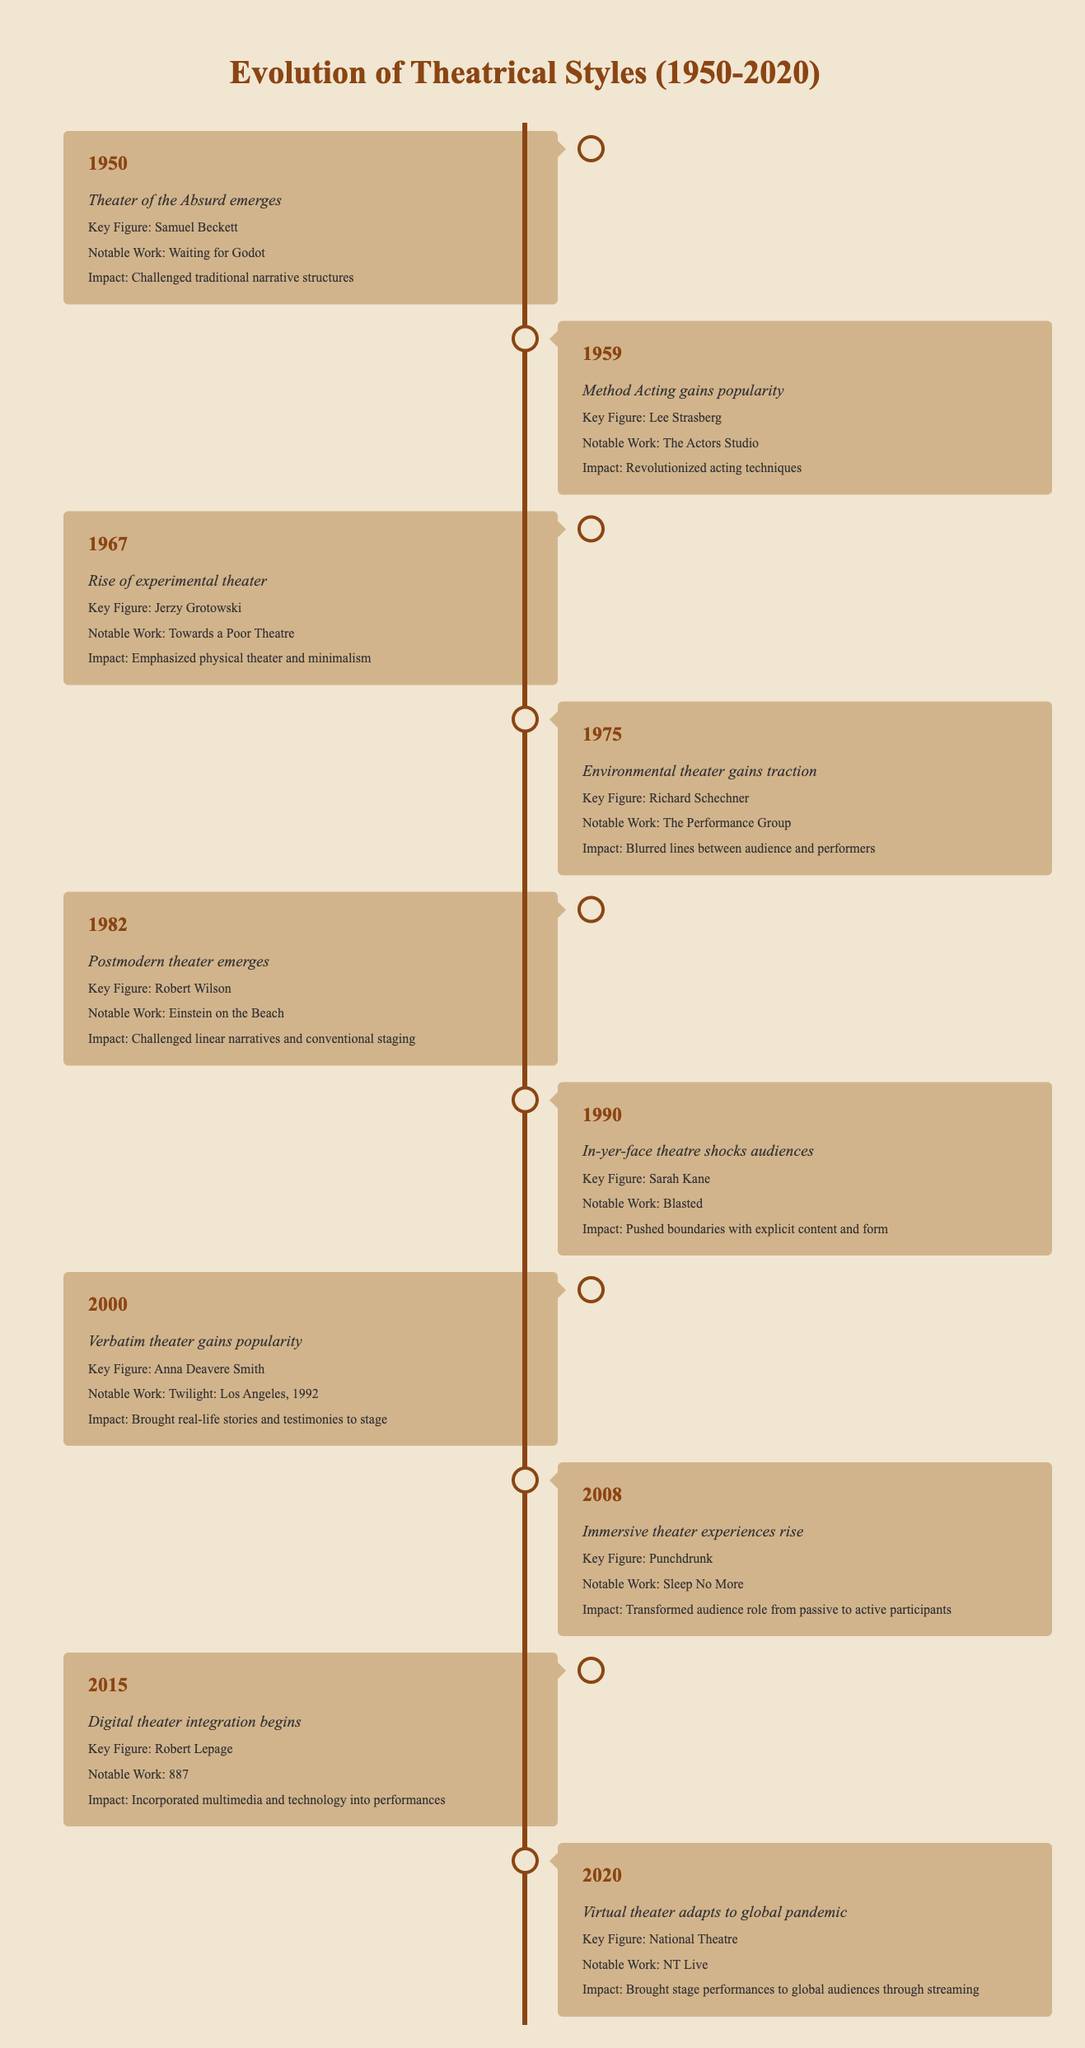What year did the Theater of the Absurd emerge? The table shows that the event "Theater of the Absurd emerges" occurred in the year 1950.
Answer: 1950 Who is the key figure associated with Postmodern theater? Referring to the row for the year 1982, the key figure associated with Postmodern theater is Robert Wilson.
Answer: Robert Wilson What notable work is linked to the environmental theater? Looking at the 1975 entry, the notable work linked to Environmental theater is "The Performance Group."
Answer: The Performance Group Did in-yer-face theatre emerge before or after 2000? Each entry is arranged chronologically, and since in-yer-face theatre is listed in 1990, which is before 2000.
Answer: Before How many theatrical styles are mentioned in the timeline? Counting each unique theatrical style listed in the events: Theater of the Absurd, Method Acting, Experimental theater, Environmental theater, Postmodern theater, In-yer-face theatre, Verbatim theater, Immersive theater, Digital theater, and Virtual theater, we find a total of 10 styles.
Answer: 10 Which event emphasized physical theater and minimalism? Referring to the 1967 entry, the event that emphasized physical theater and minimalism is "Rise of experimental theater."
Answer: Rise of experimental theater Is "Waiting for Godot" a notable work of the 1990s? The notable work "Waiting for Godot" is listed under the 1950 entry, indicating it is not from the 1990s.
Answer: No What is the impact of digital theater integration according to the timeline? The timeline states that the impact of digital theater integration is that it "Incorporated multimedia and technology into performances."
Answer: Incorporated multimedia and technology into performances What was the last theatrical style mentioned in the timeline? The last entry in the table refers to the year 2020, which mentions "Virtual theater adapts to global pandemic." Therefore, this is the last theatrical style mentioned.
Answer: Virtual theater 